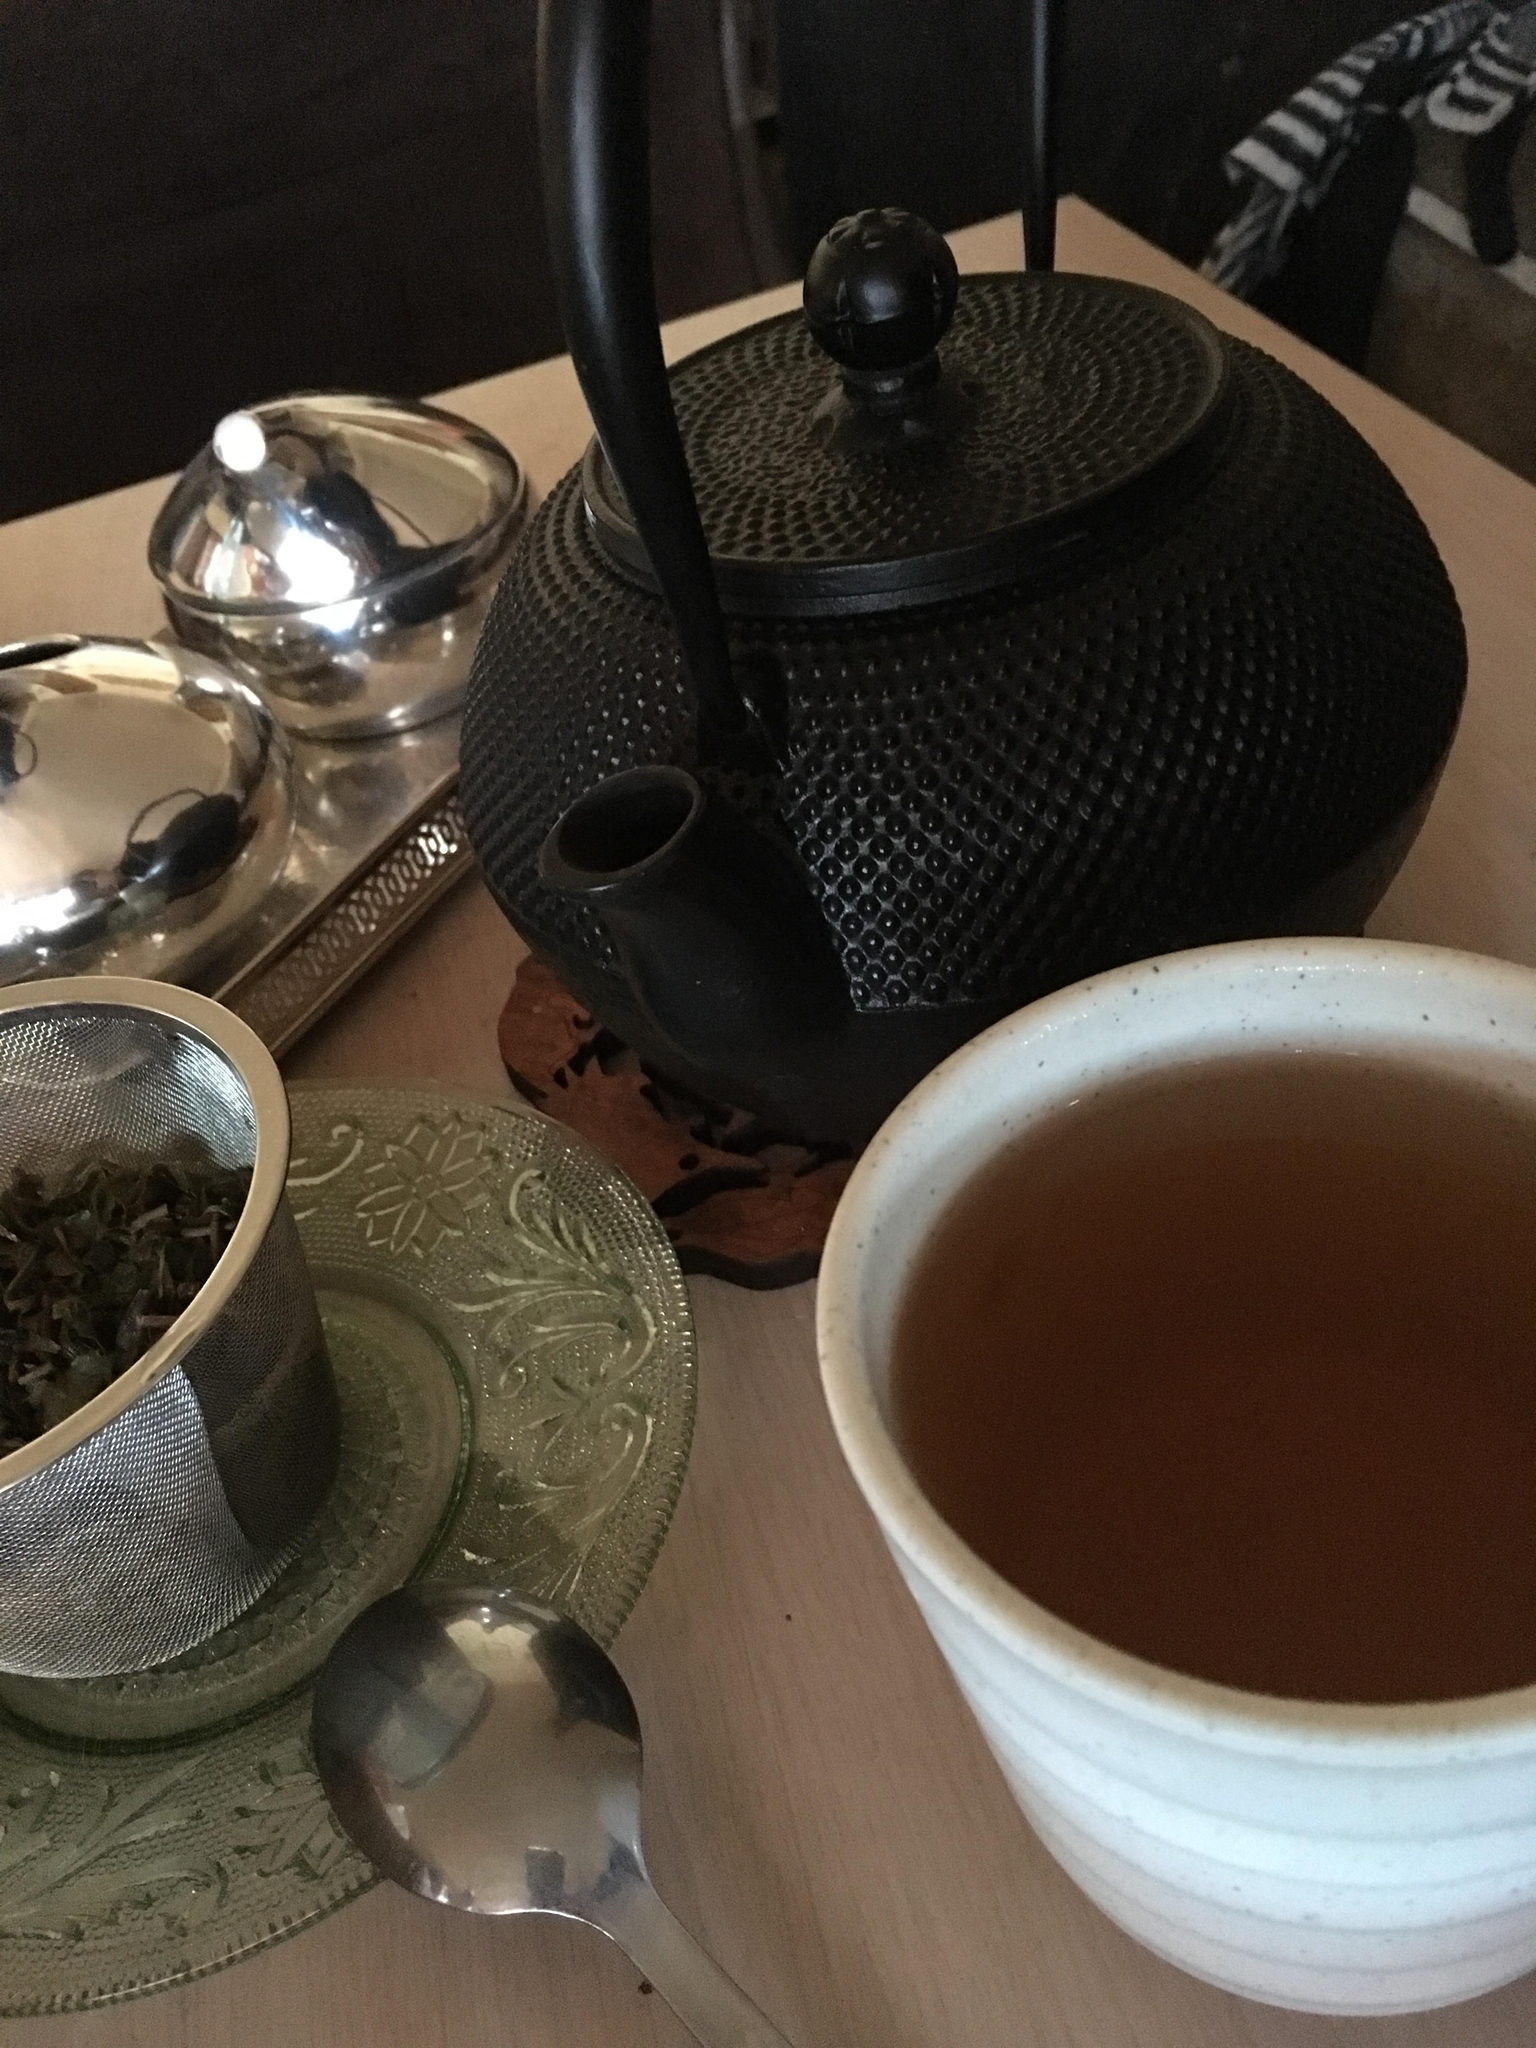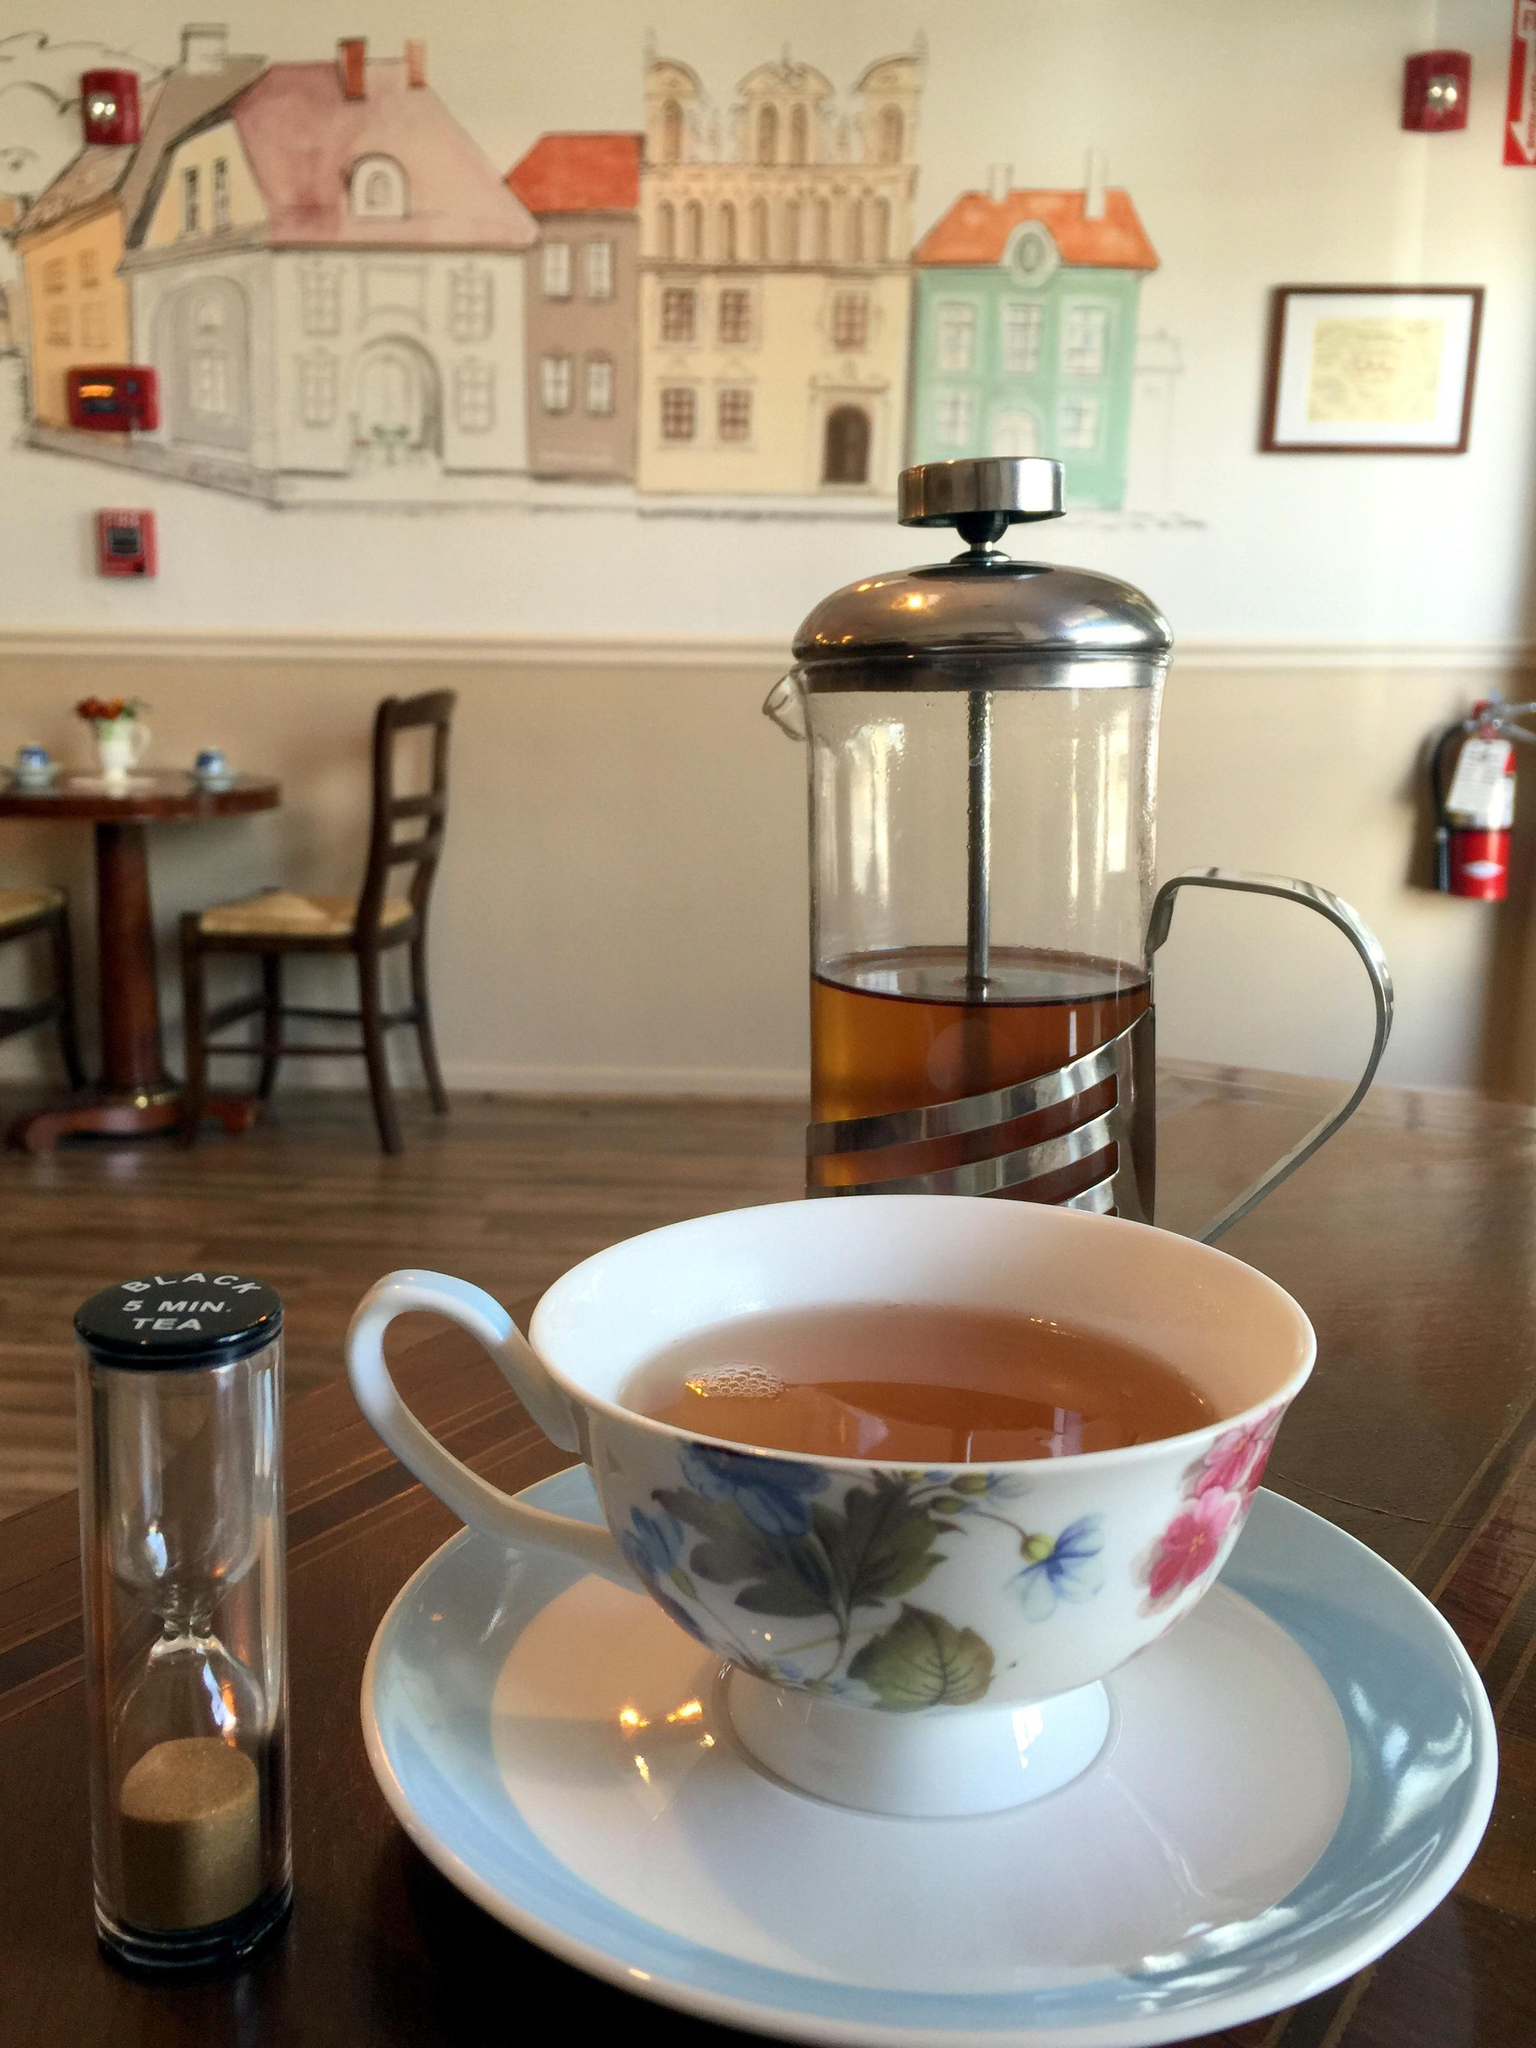The first image is the image on the left, the second image is the image on the right. Examine the images to the left and right. Is the description "The right image includes a porcelain cup with flowers on it sitting on a saucer in front of a container with a spout." accurate? Answer yes or no. Yes. The first image is the image on the left, the second image is the image on the right. Assess this claim about the two images: "Any cups in the left image are solid white and any cups in the right image are not solid white.". Correct or not? Answer yes or no. Yes. 